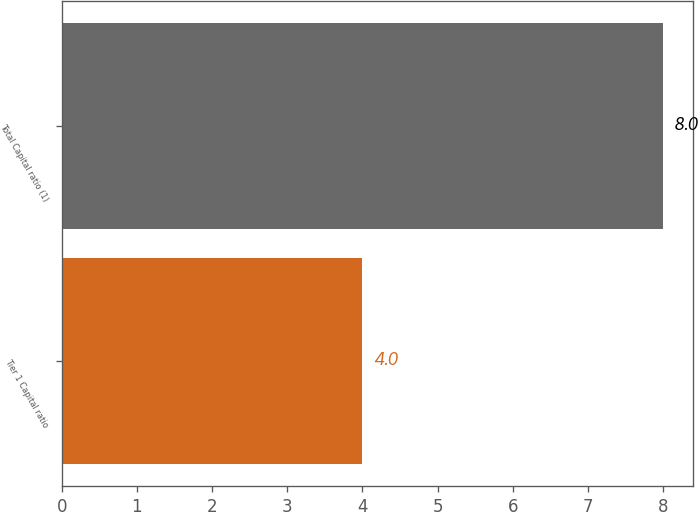<chart> <loc_0><loc_0><loc_500><loc_500><bar_chart><fcel>Tier 1 Capital ratio<fcel>Total Capital ratio (1)<nl><fcel>4<fcel>8<nl></chart> 